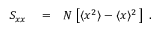Convert formula to latex. <formula><loc_0><loc_0><loc_500><loc_500>\begin{array} { r l r } { S _ { x x } } & = } & { N \, \left [ \langle \/ x ^ { 2 } \rangle - \langle \/ x \/ \rangle ^ { 2 } \, \right ] \ . } \end{array}</formula> 